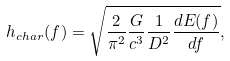<formula> <loc_0><loc_0><loc_500><loc_500>h _ { c h a r } ( f ) = \sqrt { \frac { 2 } { \pi ^ { 2 } } \frac { G } { c ^ { 3 } } \frac { 1 } { D ^ { 2 } } \frac { d E ( f ) } { d f } } ,</formula> 